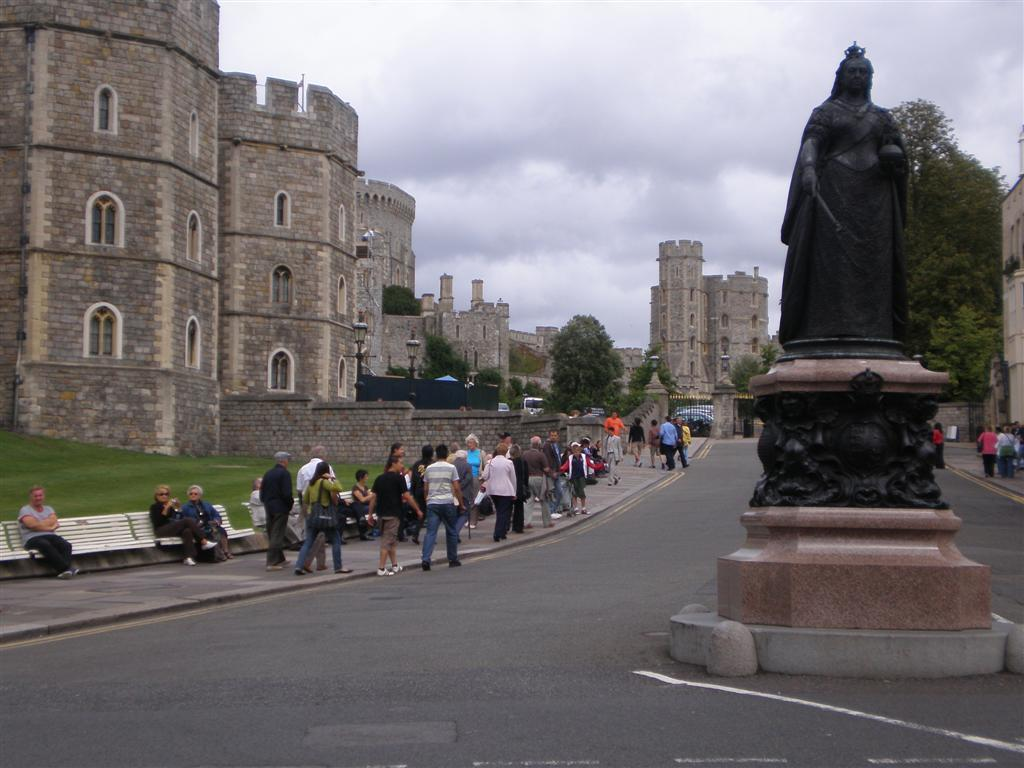What type of structures can be seen in the image? There are buildings in the image. What are the tall, vertical objects in the image? There are light poles in the image. What type of natural elements are present in the image? There are trees in the image. How would you describe the sky in the image? The sky is cloudy in the image. What is a prominent feature in the image? There is a statue in the image. What type of ground cover is visible in the image? There is grass in the image. What type of seating is available in the image? There are benches in the image. Are there any people in the image? Yes, there are people in the image. What type of pathway is present in the image? There is a road in the image. What else can be seen in the image besides the mentioned elements? There are objects in the image. What are some people doing while sitting on the benches? Some people are sitting on the benches. What type of tax is being discussed by the people in the image? There is no indication in the image that people are discussing taxes. What type of power source is being used by the statue in the image? The image does not provide information about the statue's power source. What type of disease is affecting the trees in the image? There is no indication in the image that the trees are affected by any disease. 